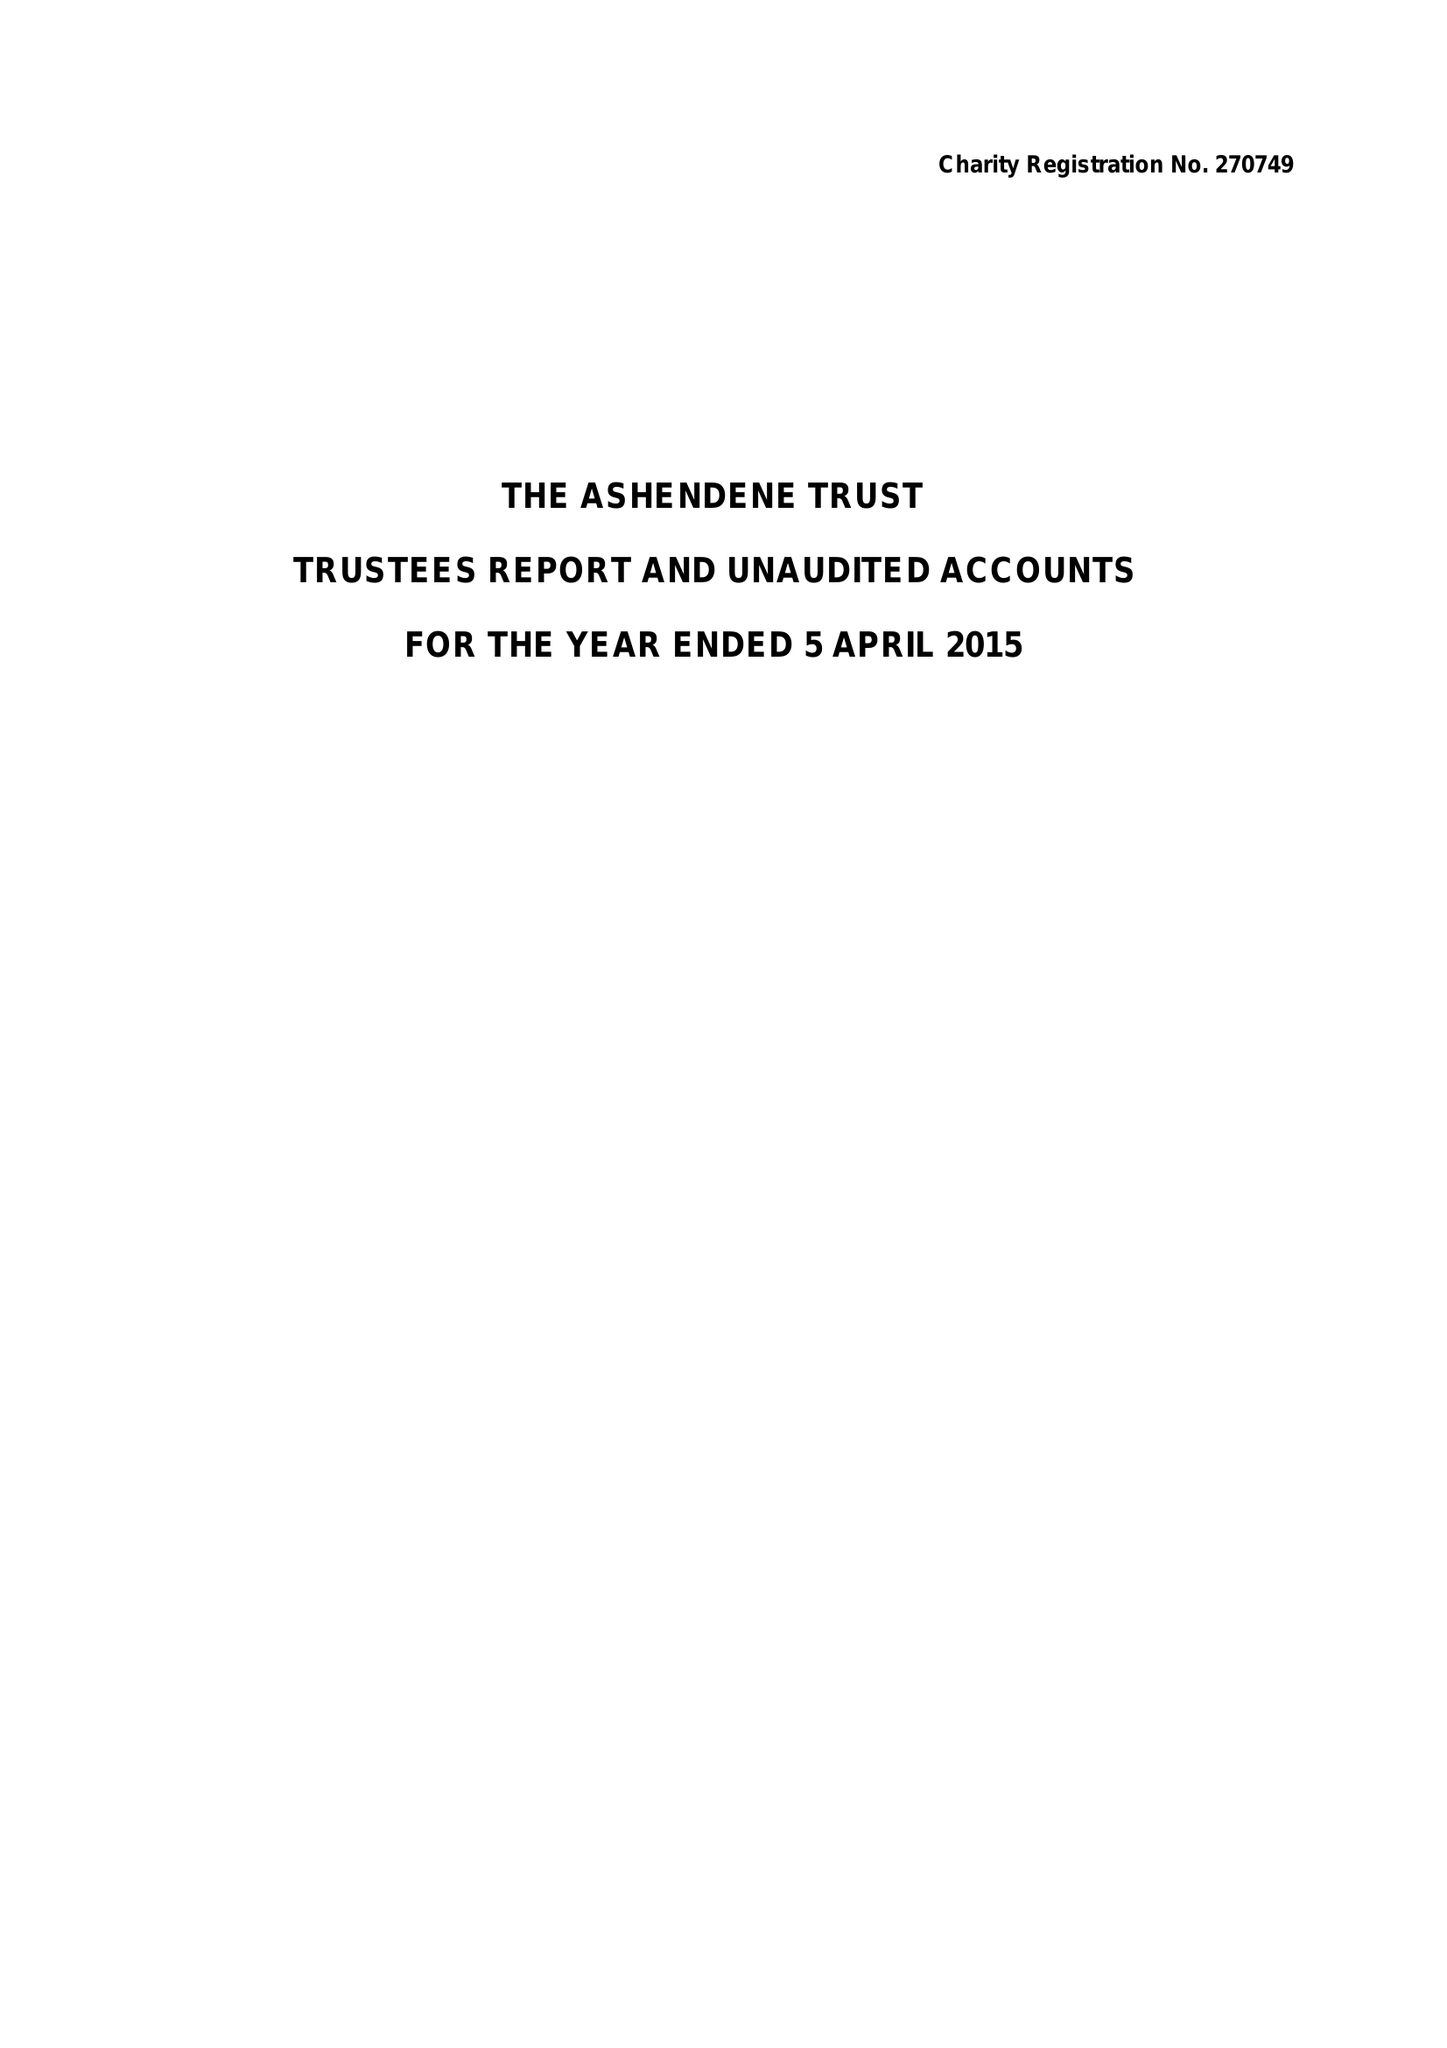What is the value for the spending_annually_in_british_pounds?
Answer the question using a single word or phrase. 52730.00 